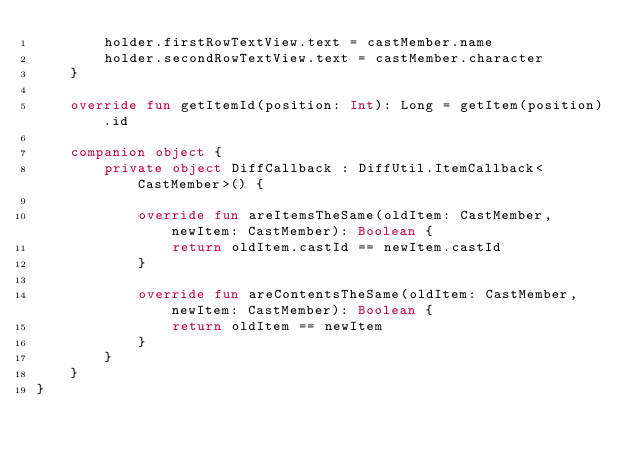<code> <loc_0><loc_0><loc_500><loc_500><_Kotlin_>        holder.firstRowTextView.text = castMember.name
        holder.secondRowTextView.text = castMember.character
    }

    override fun getItemId(position: Int): Long = getItem(position).id

    companion object {
        private object DiffCallback : DiffUtil.ItemCallback<CastMember>() {

            override fun areItemsTheSame(oldItem: CastMember, newItem: CastMember): Boolean {
                return oldItem.castId == newItem.castId
            }

            override fun areContentsTheSame(oldItem: CastMember, newItem: CastMember): Boolean {
                return oldItem == newItem
            }
        }
    }
}
</code> 